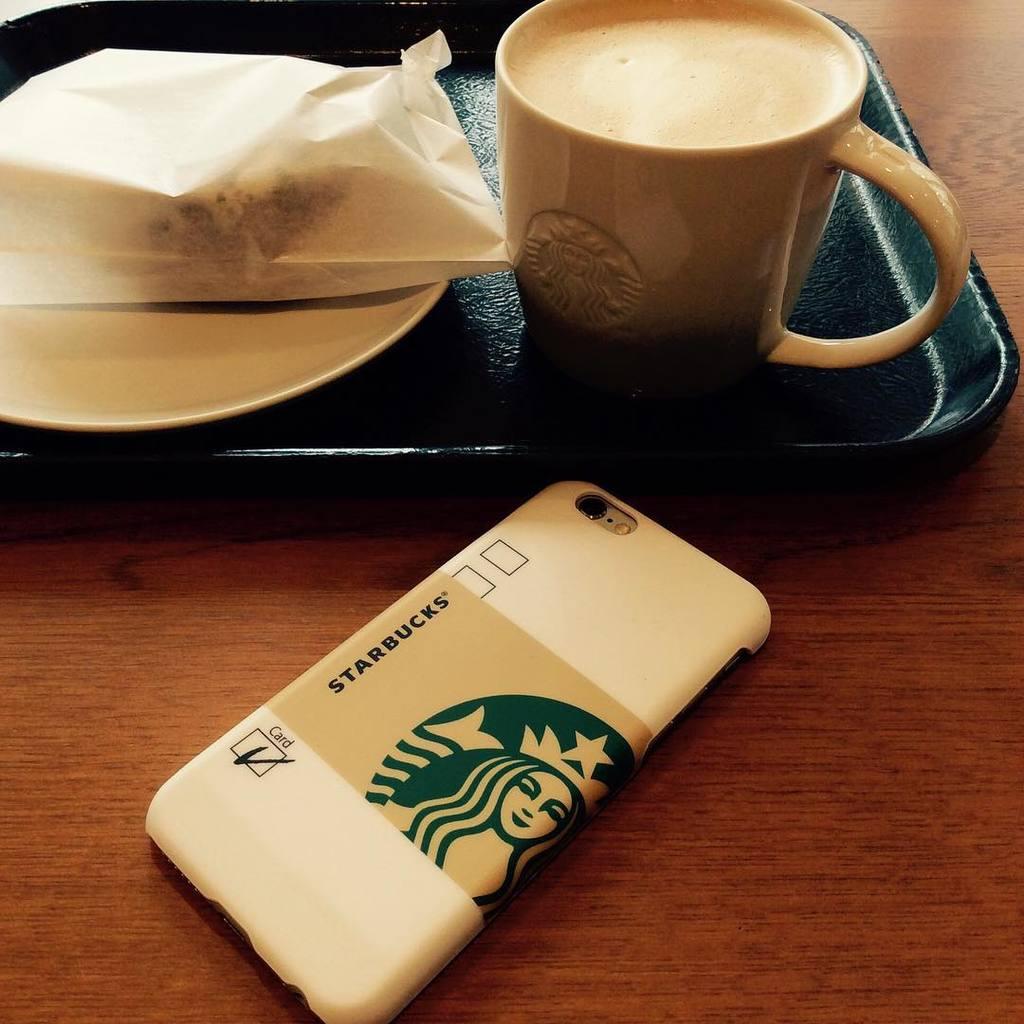What coffee company is on the back of the cell phone?
Your answer should be compact. Starbucks. What payment method is checked?
Offer a terse response. Card. 